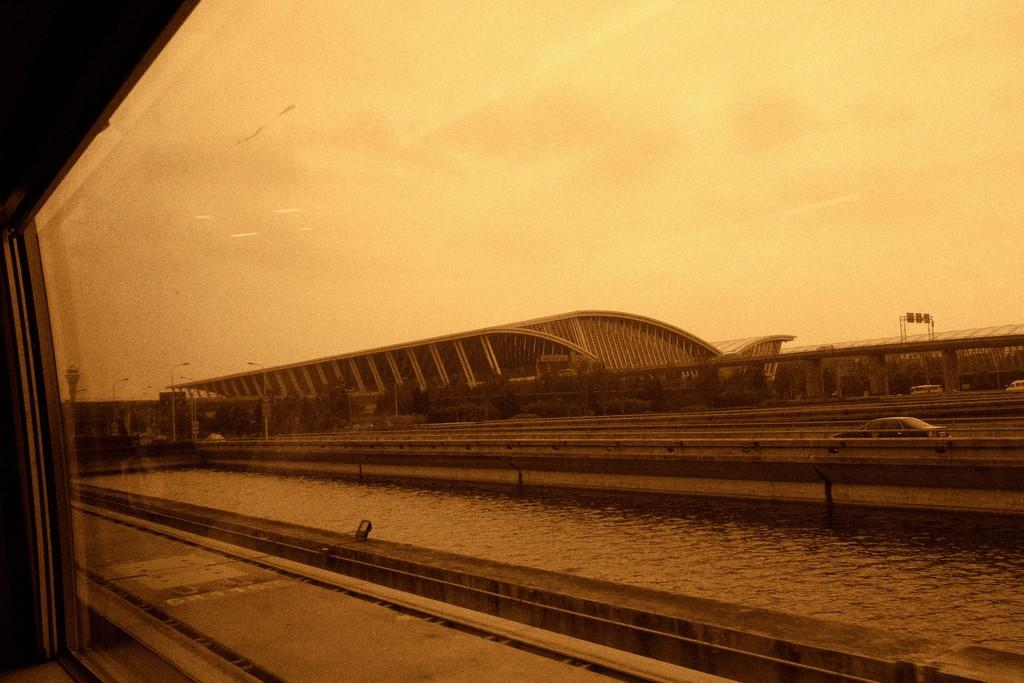What type of structure is present in the image? There is a glass window in the image. What can be seen through the window? Water is visible through the window. What is located beside the window? There are vehicles on the road beside the window. What can be seen in the background of the image? There are trees and a building in the background of the image. What emotion is the elbow displaying in the image? There is no elbow present in the image, and therefore no emotion can be attributed to it. 